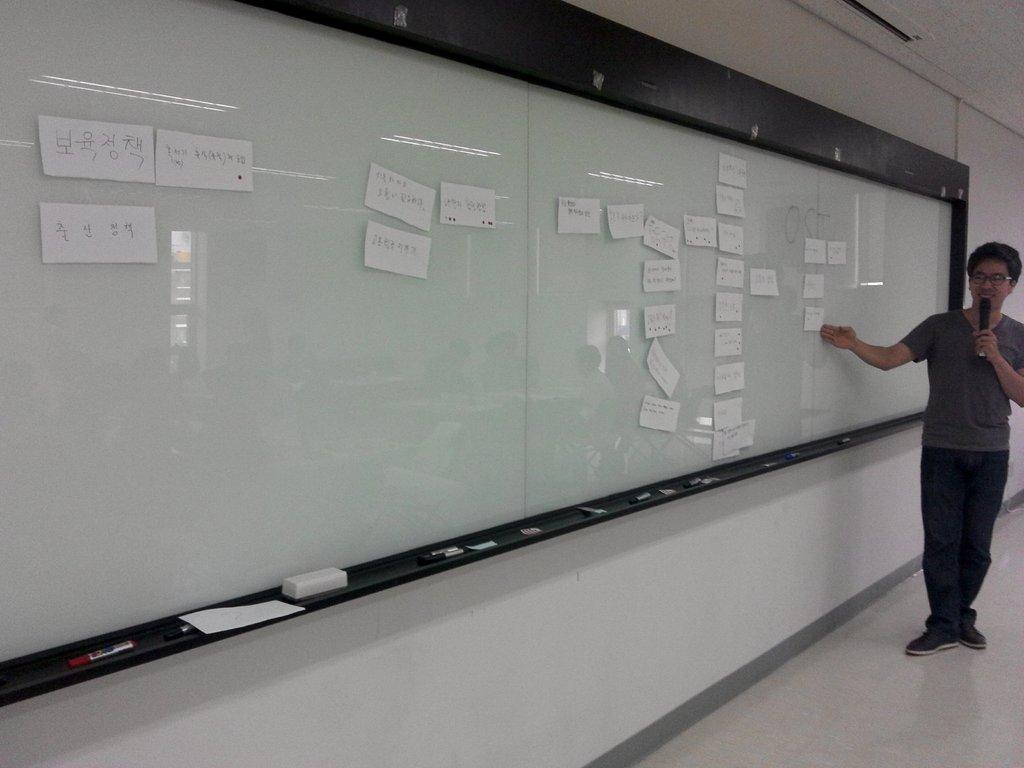Please provide a concise description of this image. On the right side there is a person wearing specs is holding a mic and standing. Near to him there is a glass board. On the board there are papers past. Near to the board there are markers and duster. And the board is on the wall. 